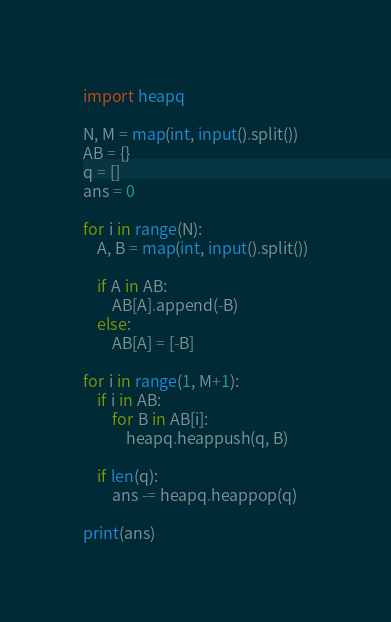<code> <loc_0><loc_0><loc_500><loc_500><_Python_>import heapq

N, M = map(int, input().split())
AB = {}
q = []
ans = 0

for i in range(N):
    A, B = map(int, input().split())
    
    if A in AB:
        AB[A].append(-B)
    else:
        AB[A] = [-B]

for i in range(1, M+1):
    if i in AB:
        for B in AB[i]:
            heapq.heappush(q, B)
        
    if len(q):
        ans -= heapq.heappop(q)
    
print(ans)    </code> 